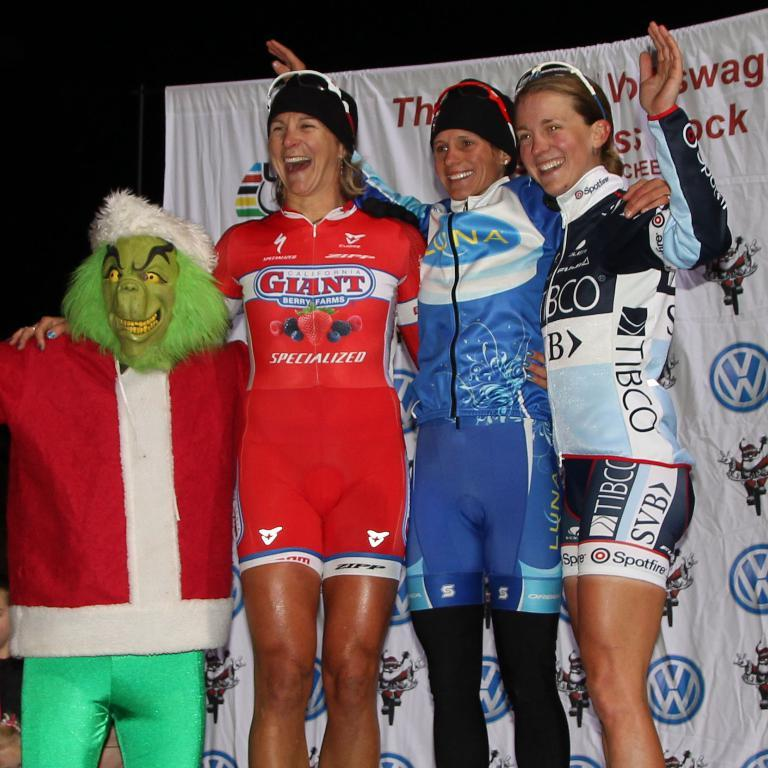<image>
Give a short and clear explanation of the subsequent image. A woman in a red shirt that says Giant on it poses with two other women and someone in a Grinch outfit. 